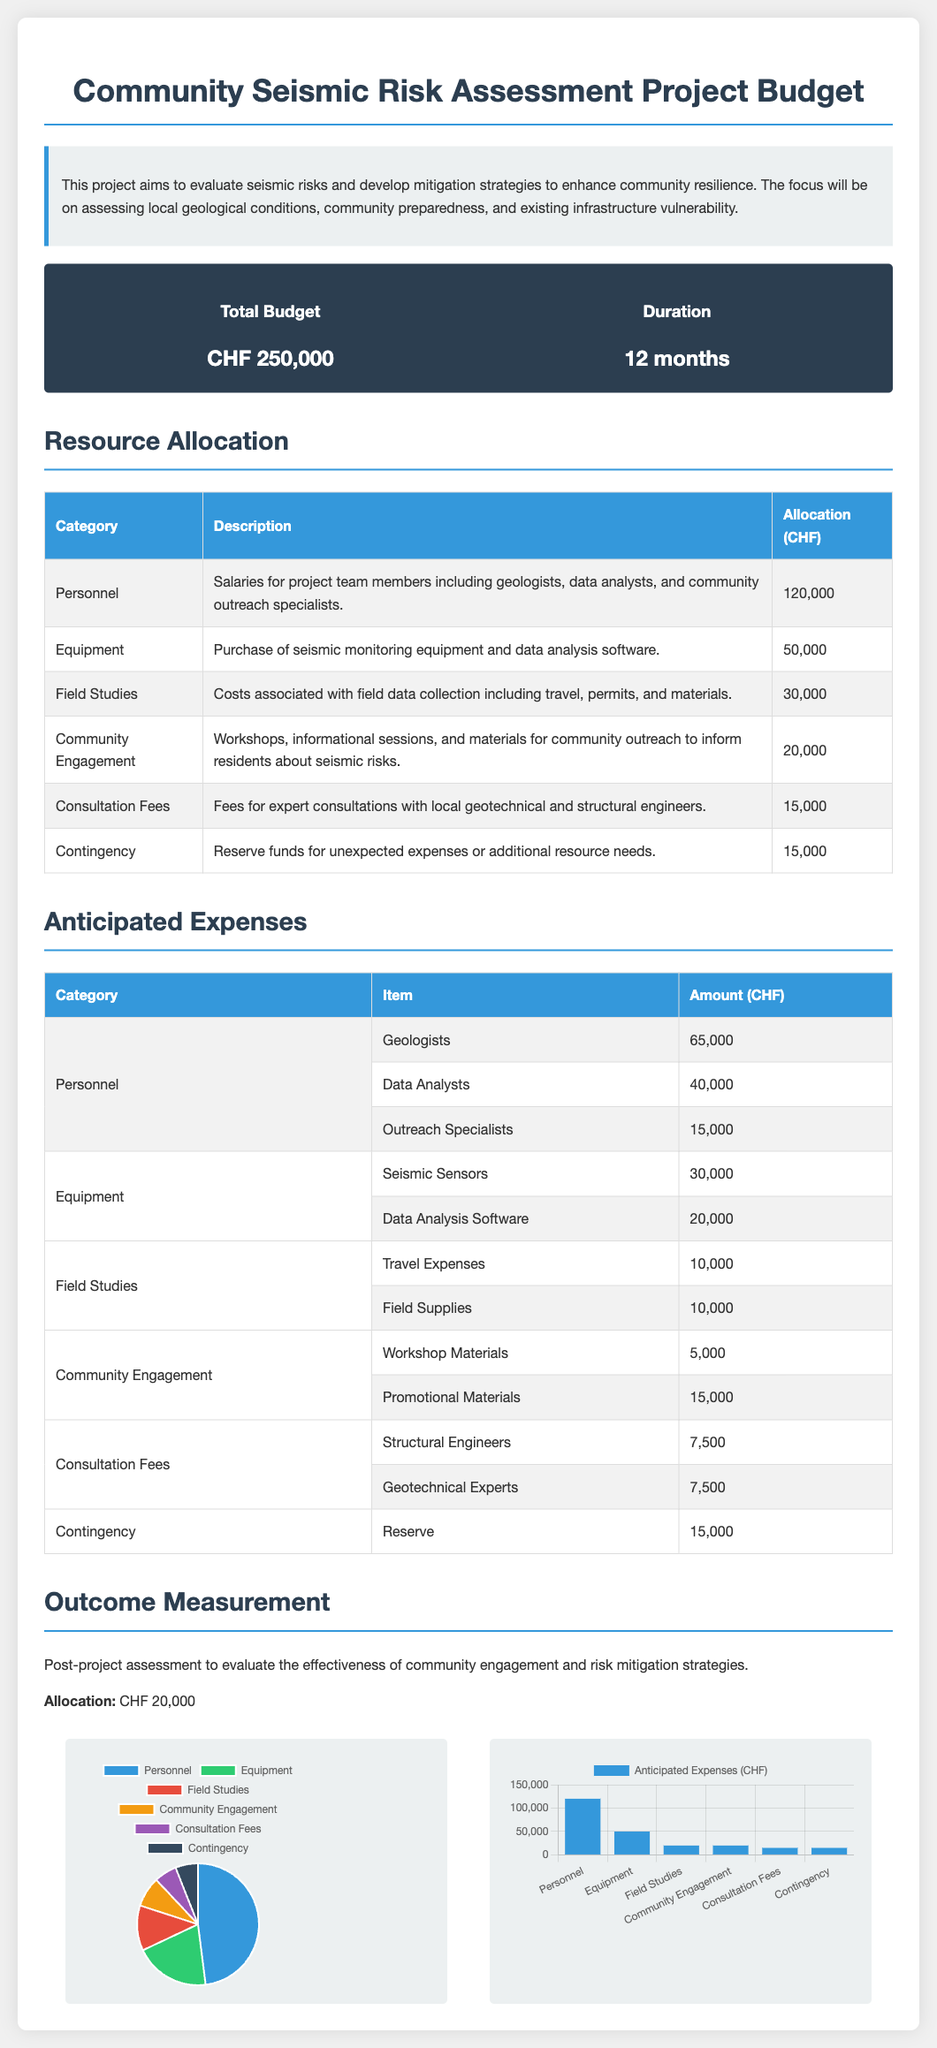what is the total budget? The total budget is specified in the overview section of the document as CHF 250,000.
Answer: CHF 250,000 what is the duration of the project? The duration of the project is mentioned in the budget overview section as 12 months.
Answer: 12 months how much is allocated to community engagement? The allocation for community engagement is listed in the resource allocation table as CHF 20,000.
Answer: CHF 20,000 how much is designated for consultation fees? Consultation fees are detailed in the resource allocation table as CHF 15,000.
Answer: CHF 15,000 who is responsible for field studies? The personnel involved in field studies includes geologists and data analysts, as inferred from the personnel section.
Answer: Geologists and data analysts what percentage of the total budget is allocated to personnel? The personnel allocation is CHF 120,000; therefore, it represents 48% of the total budget of CHF 250,000.
Answer: 48% what items fall under anticipated expenses for equipment? The anticipated expenses for equipment include seismic sensors and data analysis software.
Answer: Seismic sensors and data analysis software what is the total amount allocated for contingency? The total amount for contingency, as indicated in the resource allocation section, is CHF 15,000.
Answer: CHF 15,000 how many workshops are planned under community engagement? The document mentions workshops as part of community engagement but does not specify the number, so inference is used.
Answer: Not specified 